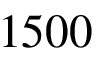<formula> <loc_0><loc_0><loc_500><loc_500>1 5 0 0</formula> 